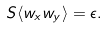<formula> <loc_0><loc_0><loc_500><loc_500>S \langle w _ { x } w _ { y } \rangle = \epsilon .</formula> 